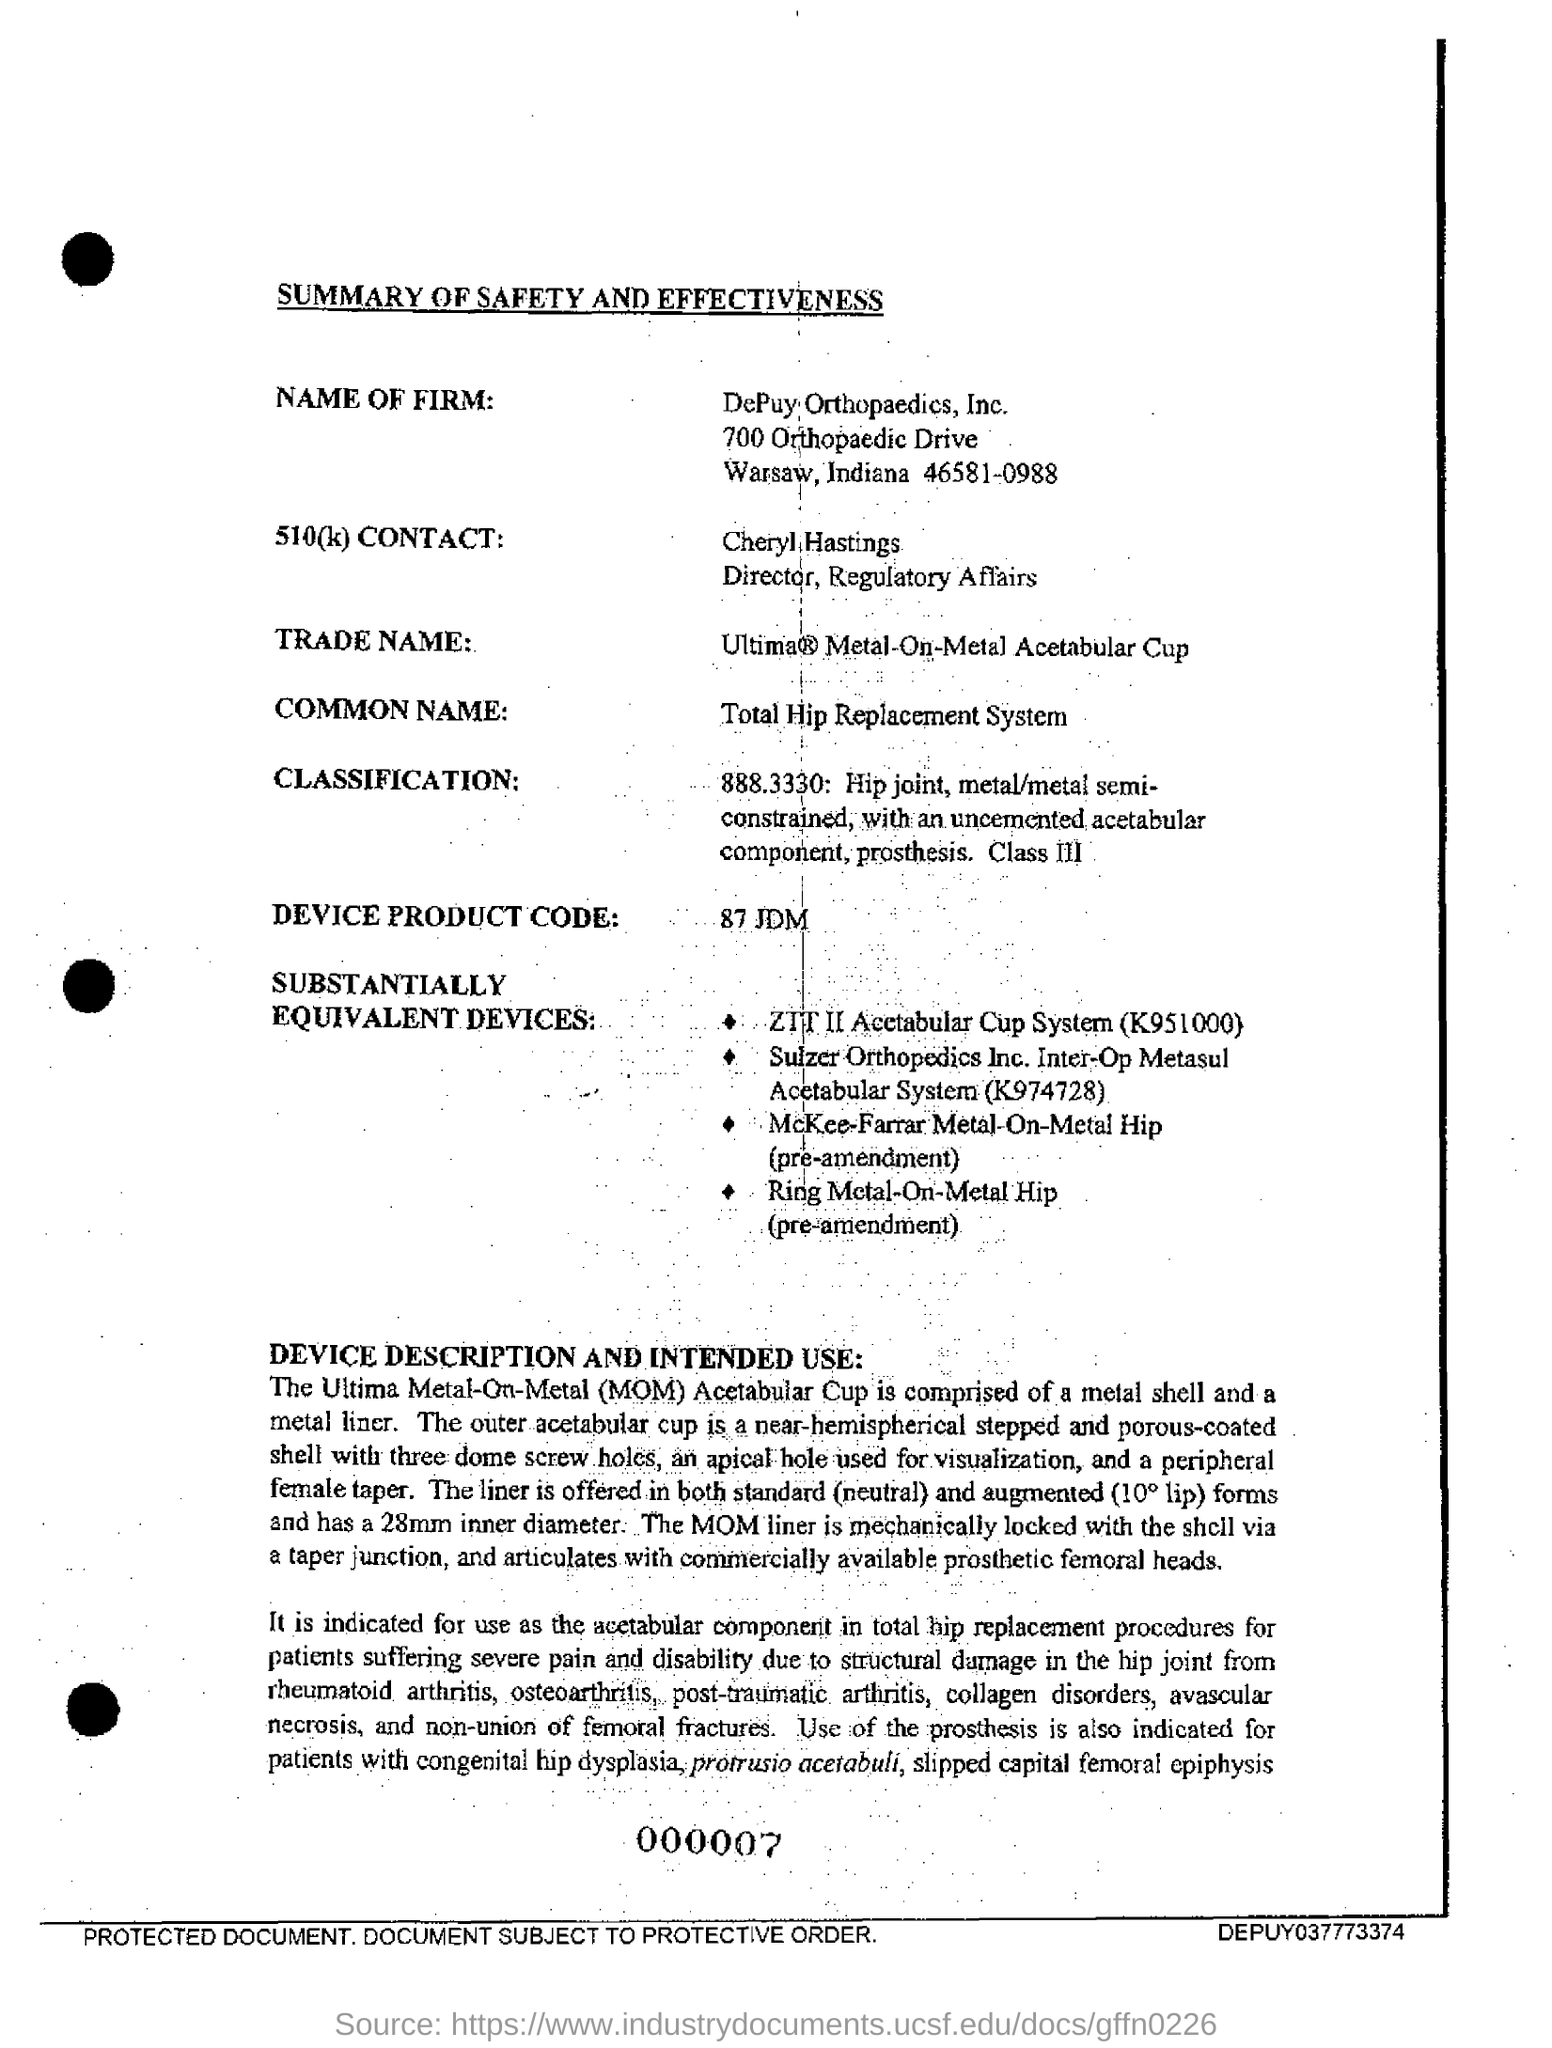What is the title of the document?
Offer a very short reply. SUMMARY OF SAFETY AND EFFECTIVENESS. What is the name of the firm given in the document?
Offer a terse response. Depuy Orthopaedics, Inc. What is the common name mentioned in the document?
Provide a short and direct response. Total Hip Replacement System. What is the full form of MOM?
Provide a succinct answer. Metal-On-Metal. 